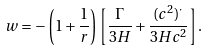Convert formula to latex. <formula><loc_0><loc_0><loc_500><loc_500>w = - \left ( 1 + \frac { 1 } { r } \right ) \left [ \frac { \Gamma } { 3 H } + \frac { ( c ^ { 2 } ) ^ { \cdot } } { 3 H c ^ { 2 } } \right ] .</formula> 